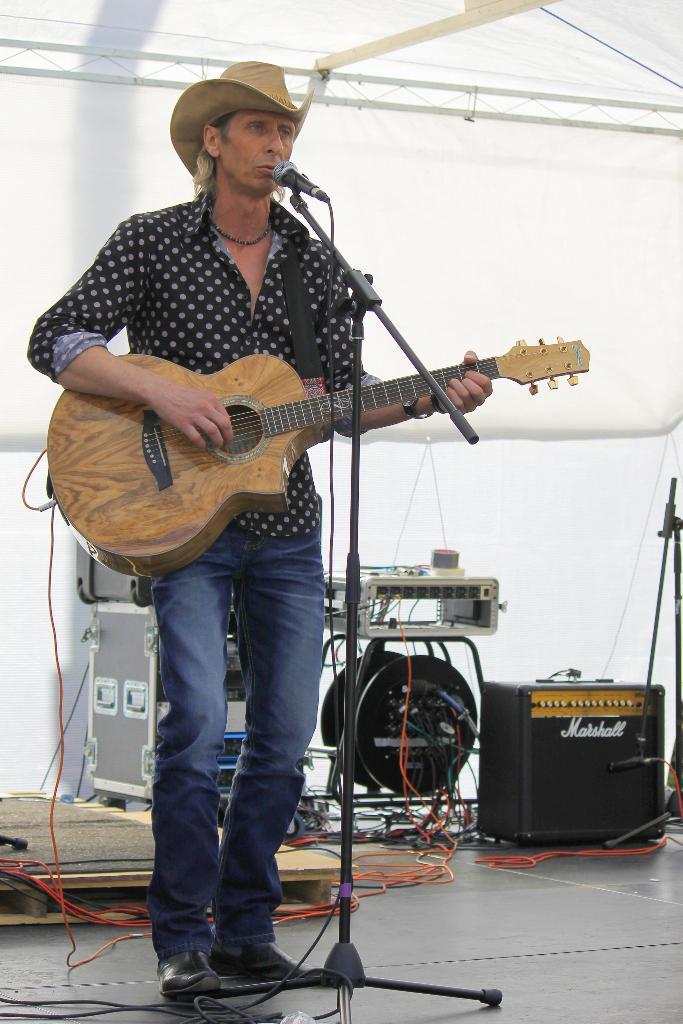Could you give a brief overview of what you see in this image? In this picture we can see a man wearing a cream colour hat , standing in front of a mike and playing guitar. These are drums behind to him and electronic devices. This is a platform. On the background we can see a white colour cloth. 